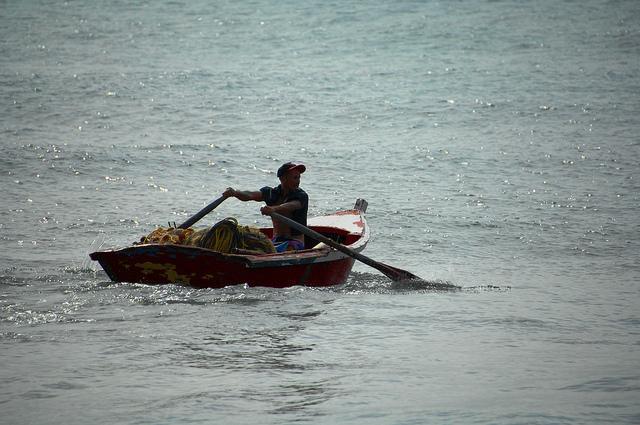How many oars can be seen?
Give a very brief answer. 2. How many people are in the boat?
Give a very brief answer. 1. How many boats are there?
Give a very brief answer. 1. How many oxygen tubes is the man in the bed wearing?
Give a very brief answer. 0. 